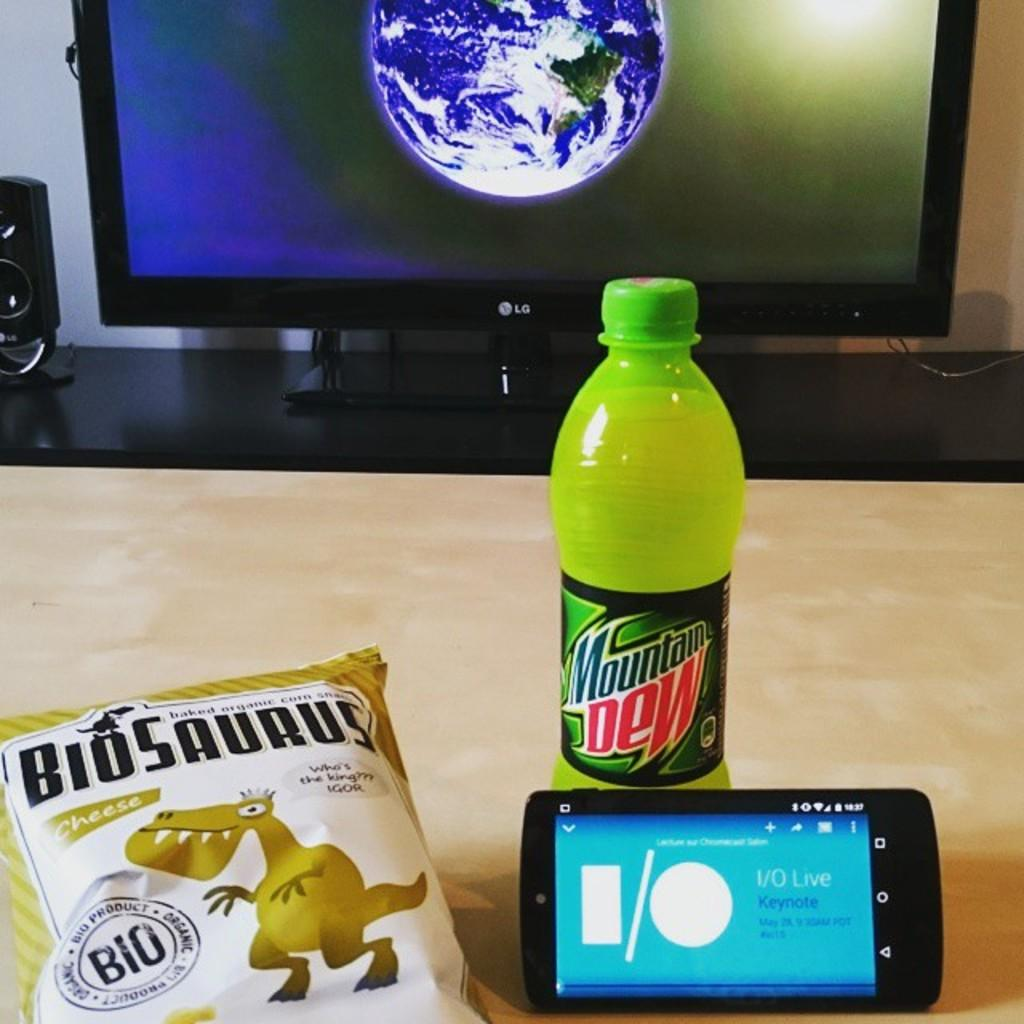<image>
Summarize the visual content of the image. Tv screen with a cell phone, Mountain Dew drink and Biosaurus snacks nearby. 